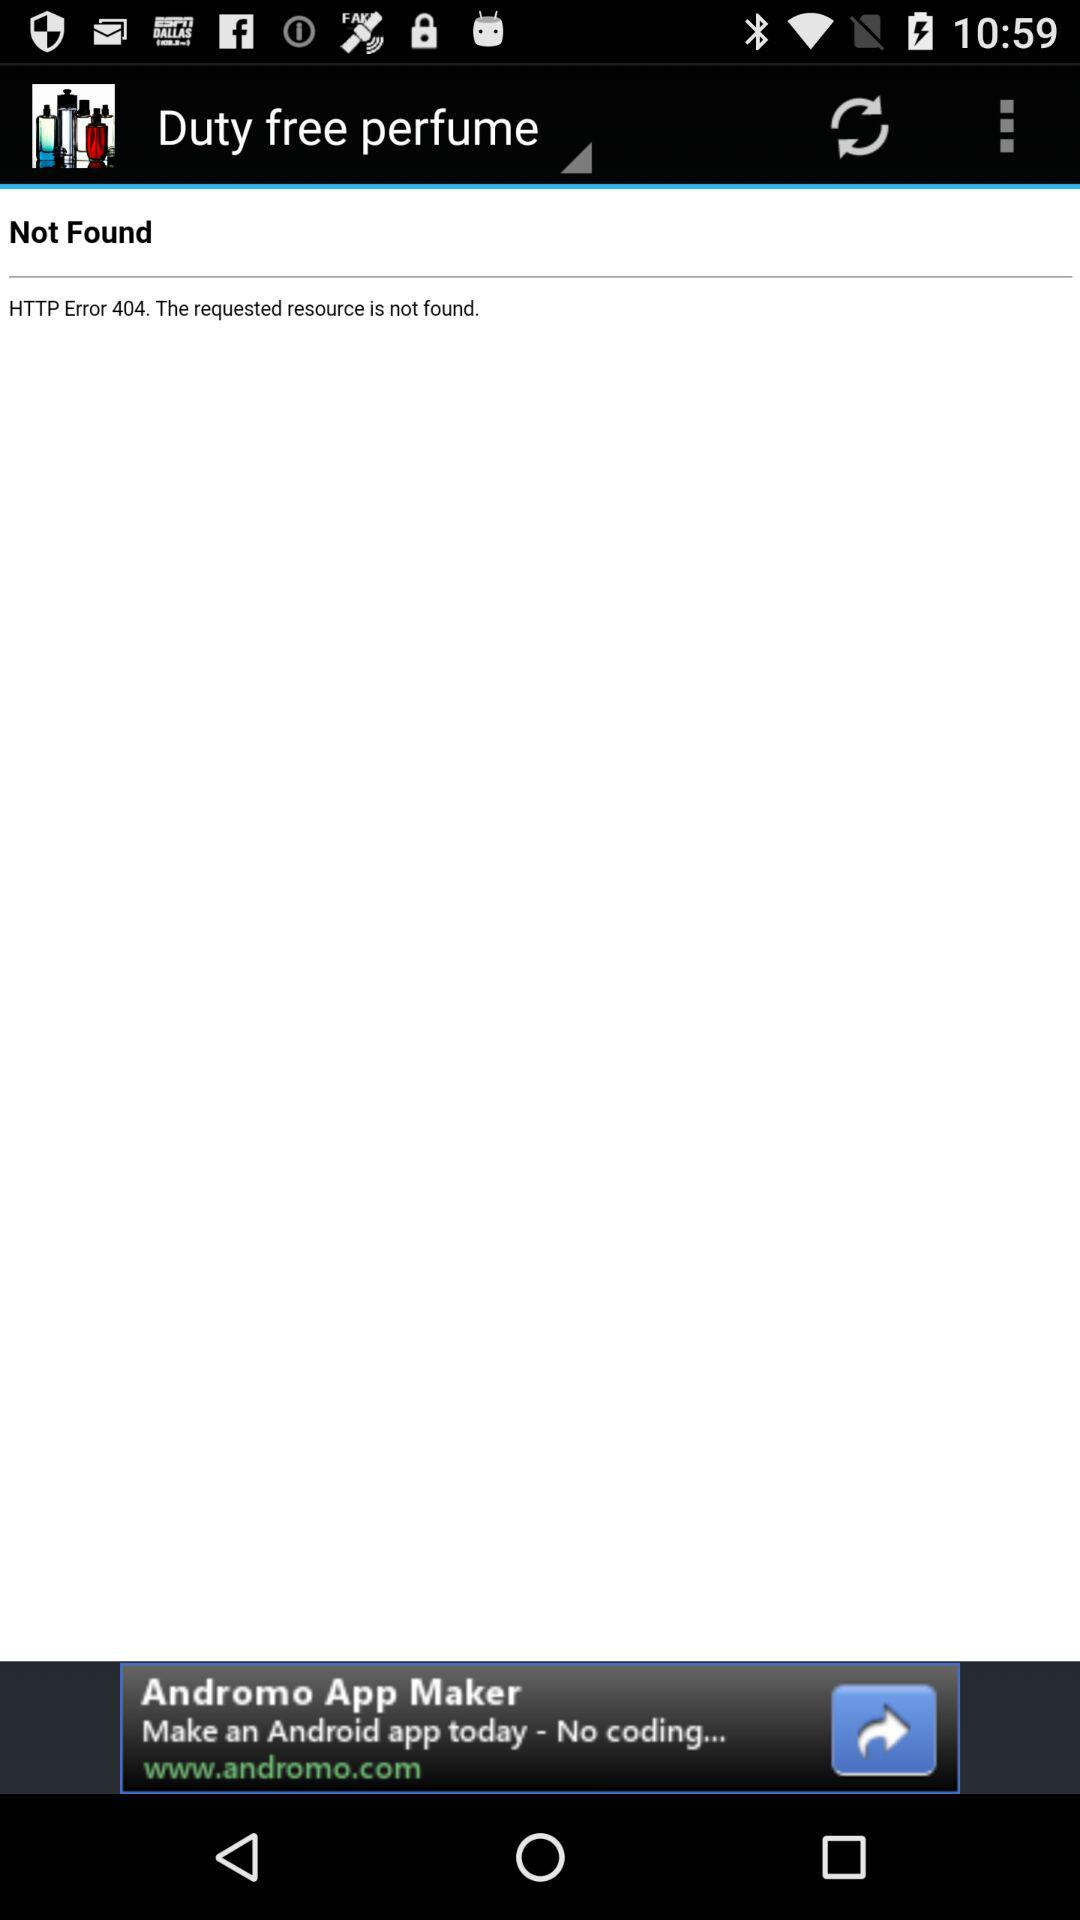What is the version of this application?
When the provided information is insufficient, respond with <no answer>. <no answer> 